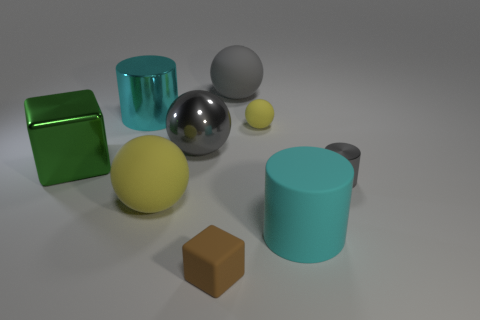What could be the purpose of arranging these geometric shapes in this way? This arrangement could serve various purposes. It might be an artistic composition, focusing on color harmony and contrast among shapes. Alternatively, it could be a setup for a 3D modeling and rendering exercise, where the objective is to demonstrate texture, lighting, and reflection effects on different surfaces. 